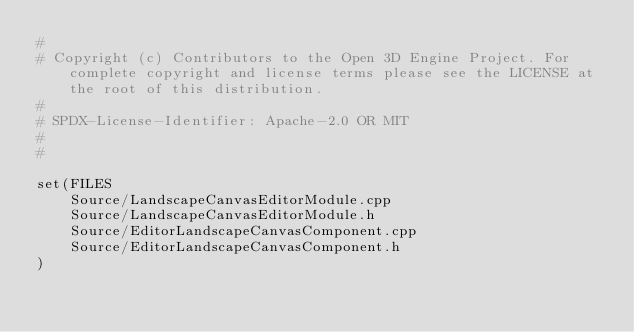<code> <loc_0><loc_0><loc_500><loc_500><_CMake_>#
# Copyright (c) Contributors to the Open 3D Engine Project. For complete copyright and license terms please see the LICENSE at the root of this distribution.
# 
# SPDX-License-Identifier: Apache-2.0 OR MIT
#
#

set(FILES
    Source/LandscapeCanvasEditorModule.cpp
    Source/LandscapeCanvasEditorModule.h
    Source/EditorLandscapeCanvasComponent.cpp
    Source/EditorLandscapeCanvasComponent.h
)
</code> 